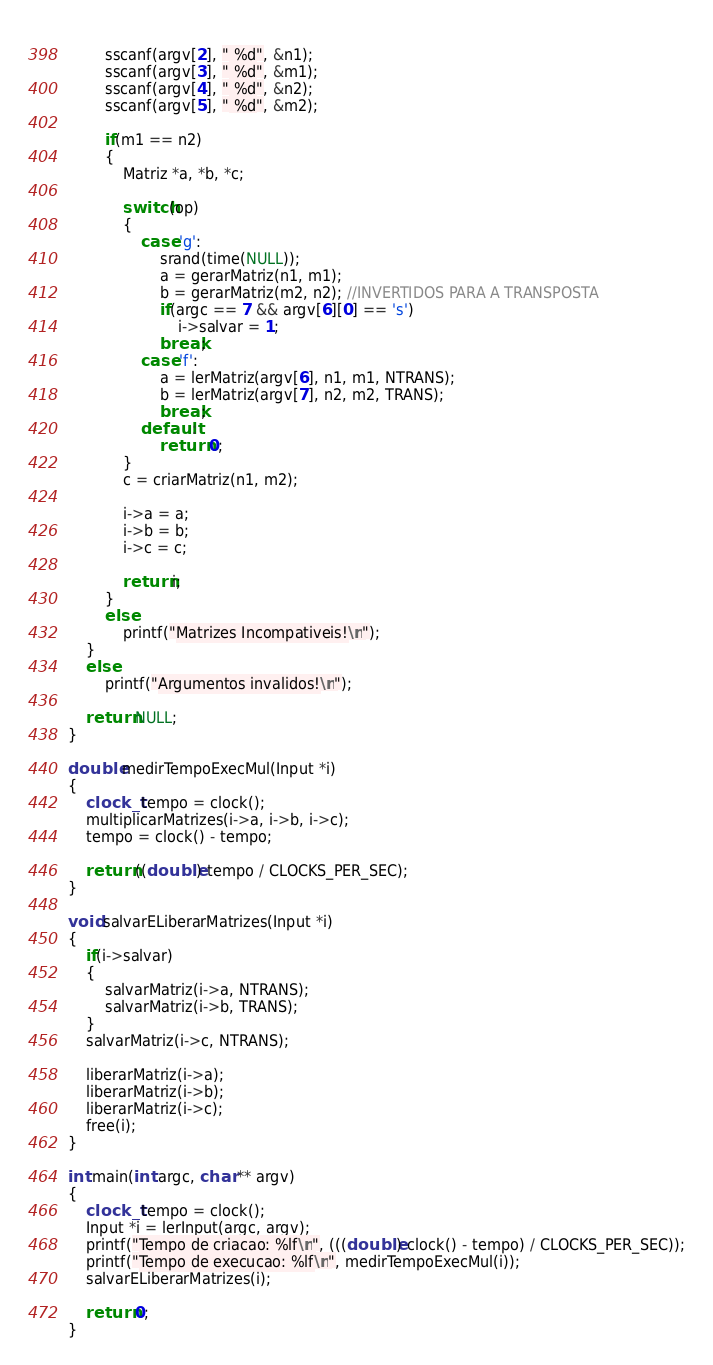<code> <loc_0><loc_0><loc_500><loc_500><_Cuda_>		
		sscanf(argv[2], " %d", &n1);
		sscanf(argv[3], " %d", &m1);
		sscanf(argv[4], " %d", &n2);
		sscanf(argv[5], " %d", &m2);
	
		if(m1 == n2)
		{
			Matriz *a, *b, *c;		
			
			switch(op)
			{
				case 'g':
					srand(time(NULL));
					a = gerarMatriz(n1, m1);
					b = gerarMatriz(m2, n2); //INVERTIDOS PARA A TRANSPOSTA
					if(argc == 7 && argv[6][0] == 's')
						i->salvar = 1;
					break;
				case 'f':
					a = lerMatriz(argv[6], n1, m1, NTRANS);
					b = lerMatriz(argv[7], n2, m2, TRANS);
					break;
				default:
					return 0;
			}
			c = criarMatriz(n1, m2);

			i->a = a;
			i->b = b;
			i->c = c;

			return i;
		}
		else
			printf("Matrizes Incompativeis!\n");
	}
	else
		printf("Argumentos invalidos!\n");

	return NULL;
}

double medirTempoExecMul(Input *i)
{
	clock_t tempo = clock();
	multiplicarMatrizes(i->a, i->b, i->c);
	tempo = clock() - tempo;

	return ((double) tempo / CLOCKS_PER_SEC);
}

void salvarELiberarMatrizes(Input *i)
{	
	if(i->salvar)
	{
		salvarMatriz(i->a, NTRANS);
		salvarMatriz(i->b, TRANS);
	}
	salvarMatriz(i->c, NTRANS);

	liberarMatriz(i->a);
	liberarMatriz(i->b);
	liberarMatriz(i->c);
	free(i);
}

int main(int argc, char ** argv)
{
	clock_t tempo = clock();
	Input *i = lerInput(argc, argv);
	printf("Tempo de criacao: %lf\n", (((double) clock() - tempo) / CLOCKS_PER_SEC));
	printf("Tempo de execucao: %lf\n", medirTempoExecMul(i));
	salvarELiberarMatrizes(i);

	return 0;
}
</code> 